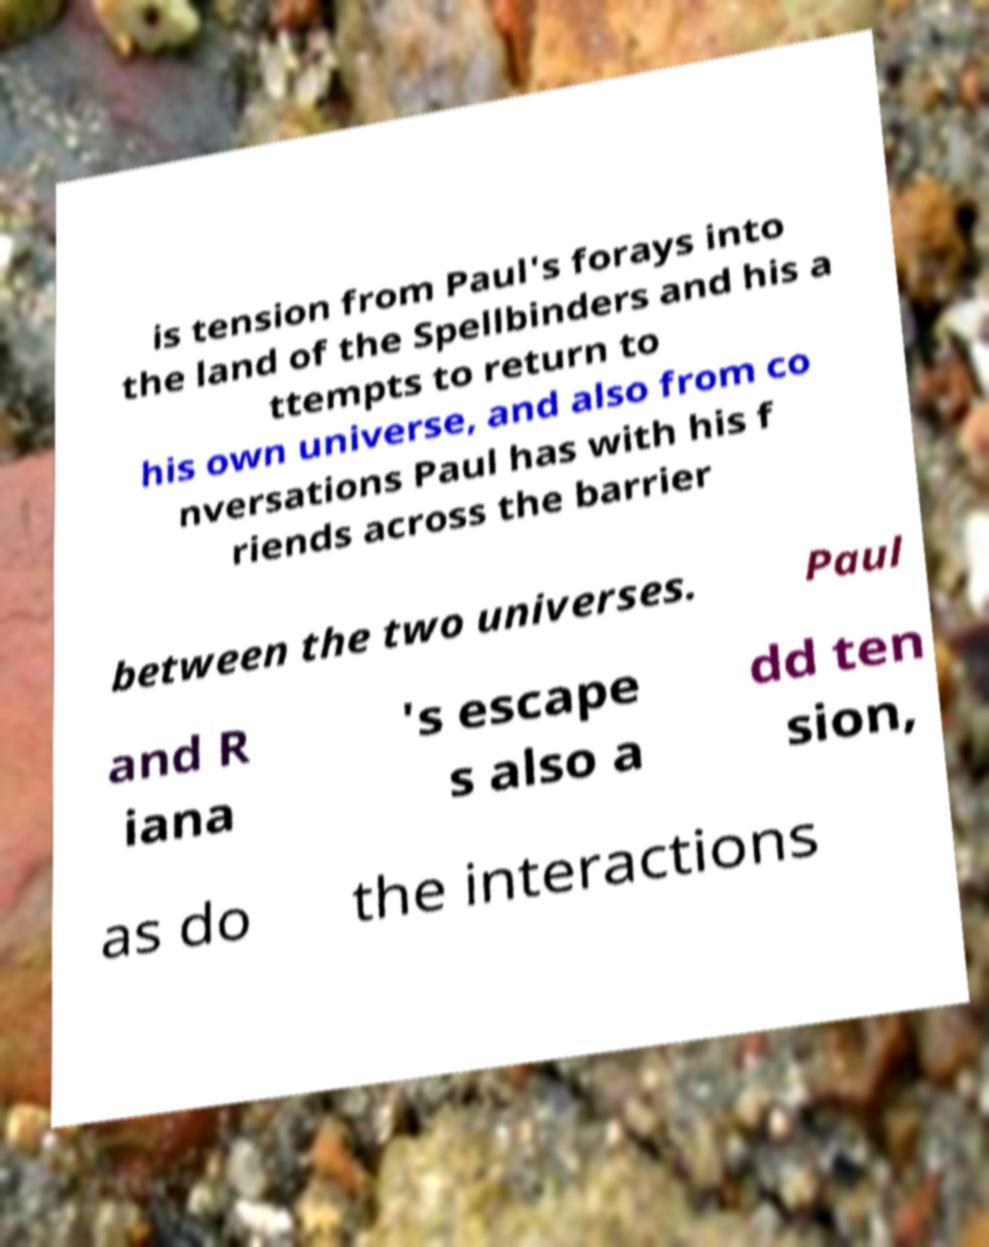I need the written content from this picture converted into text. Can you do that? is tension from Paul's forays into the land of the Spellbinders and his a ttempts to return to his own universe, and also from co nversations Paul has with his f riends across the barrier between the two universes. Paul and R iana 's escape s also a dd ten sion, as do the interactions 